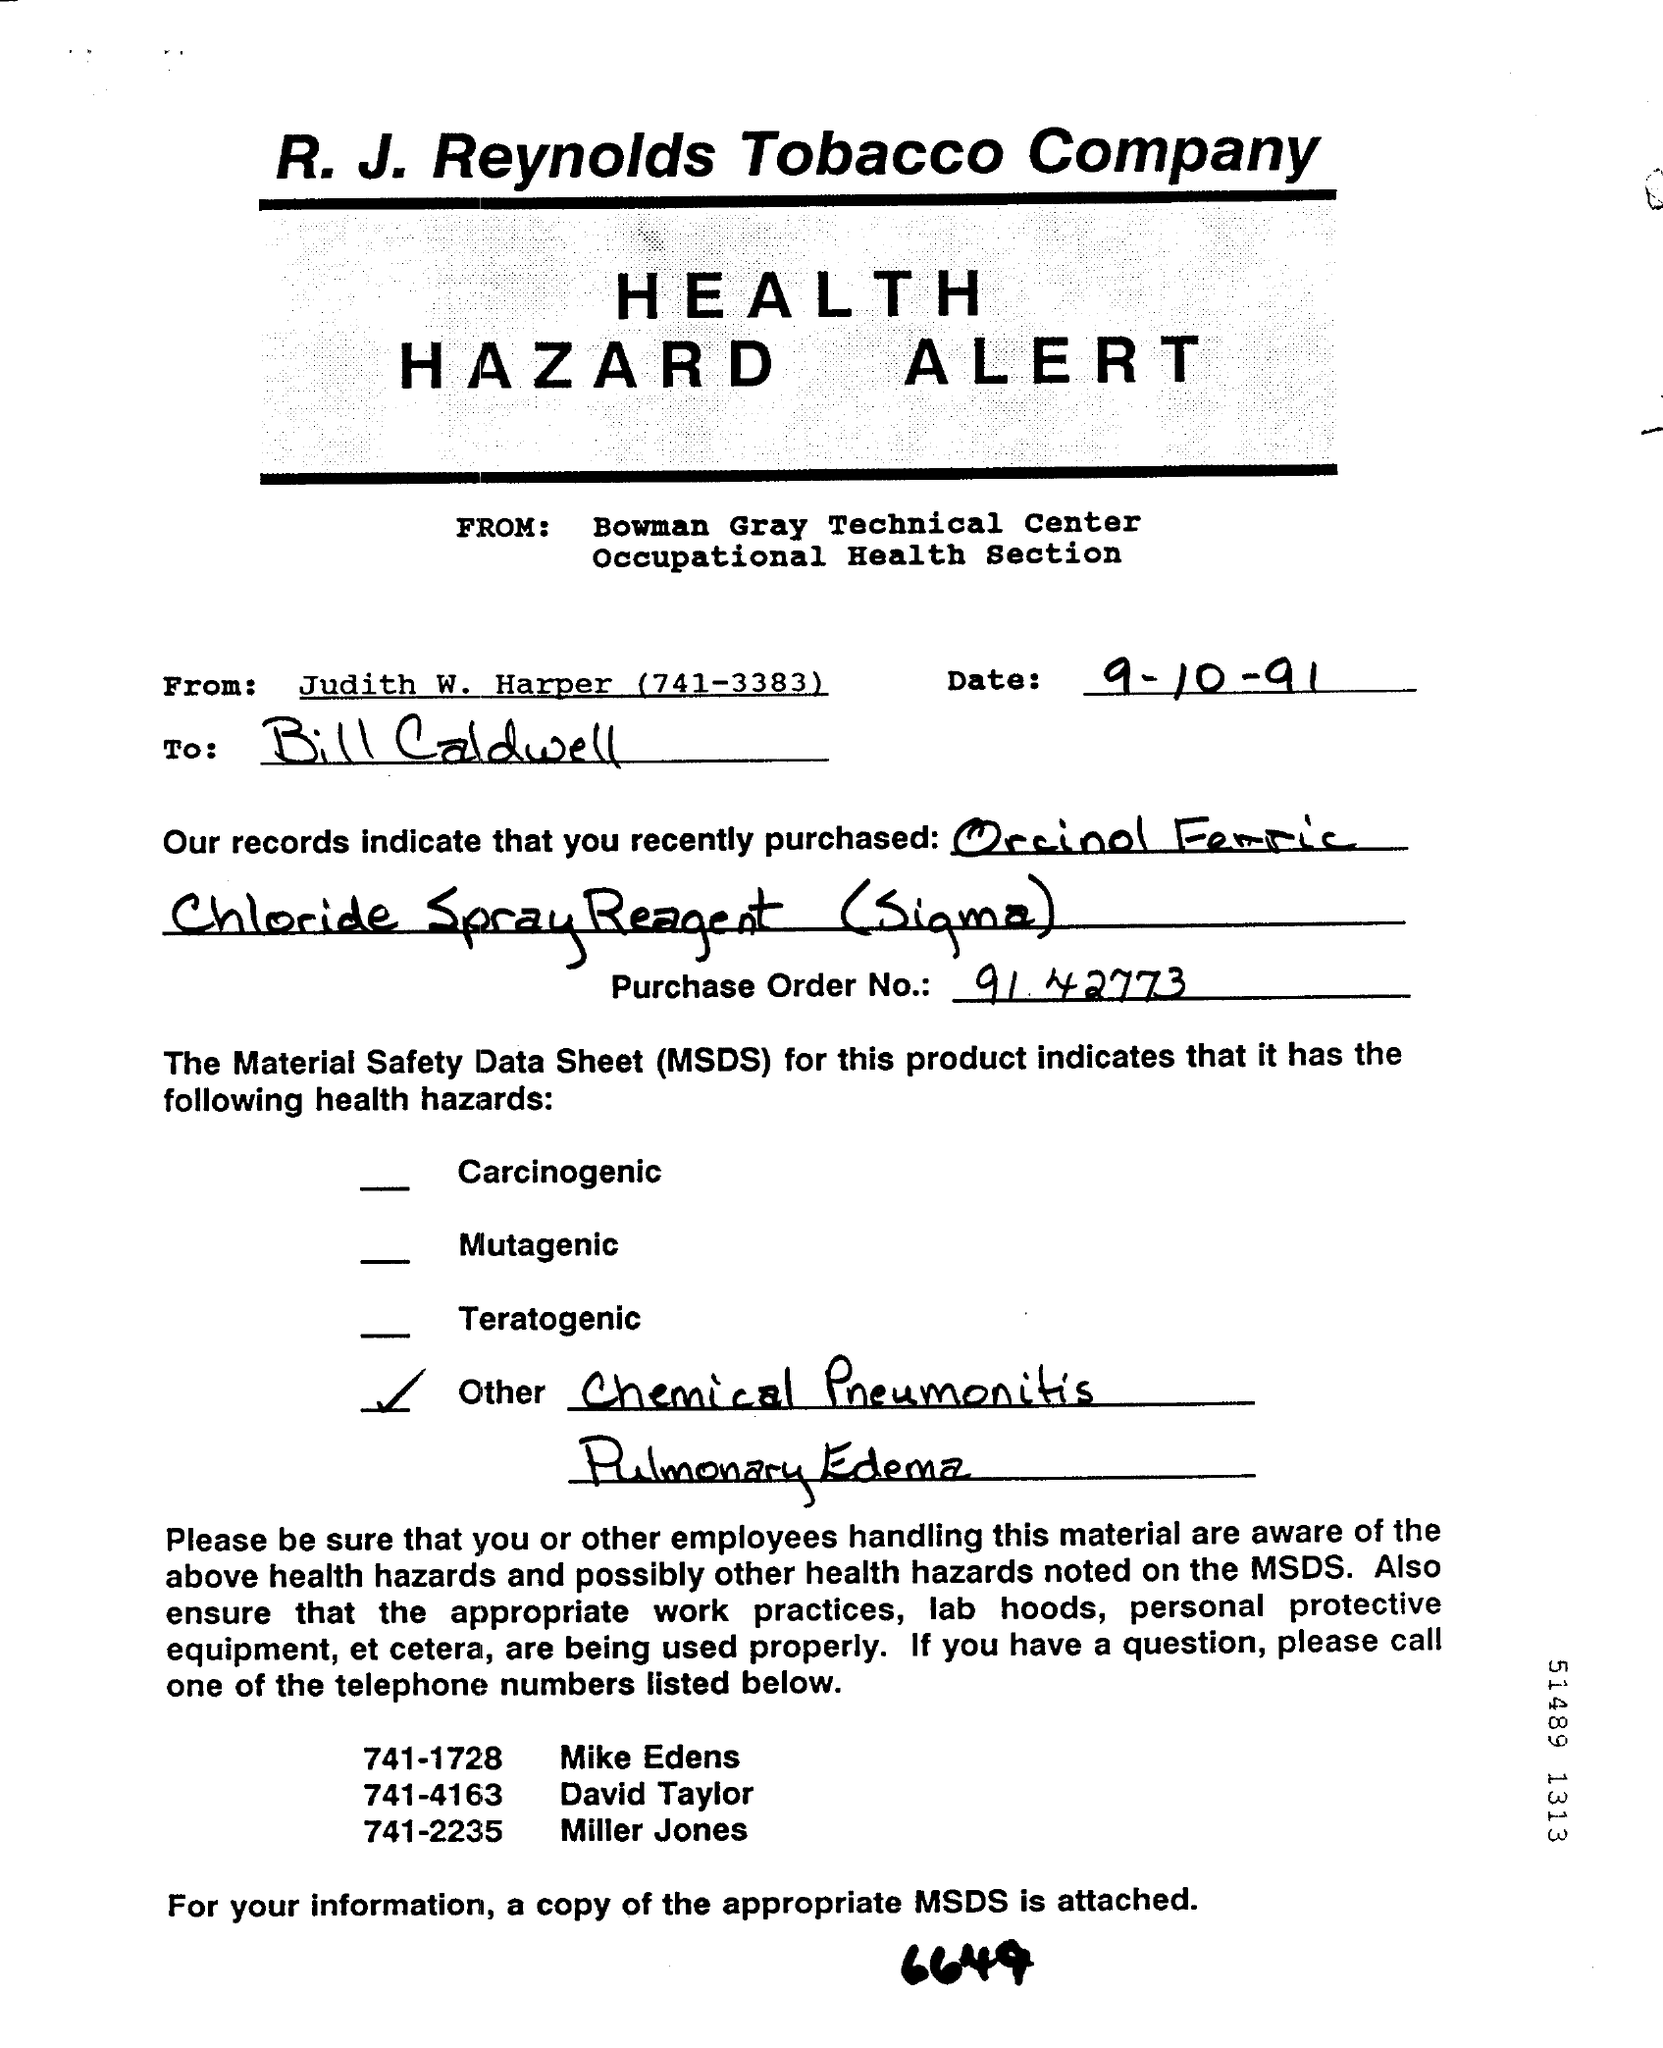What is the date mentioned ?
Offer a terse response. 9-10-91. What is the telephone number of judith w. harper ?
Give a very brief answer. (741-3383). What is the name of  the technical center ?
Offer a very short reply. Bowman gray Technical Center. MSDS stands for ?
Offer a very short reply. Material safety Data sheet. What is the telephone number of miller jones ?
Your answer should be very brief. 741-2235. What is the telephone number of david taylor ?
Give a very brief answer. 741-4163. 